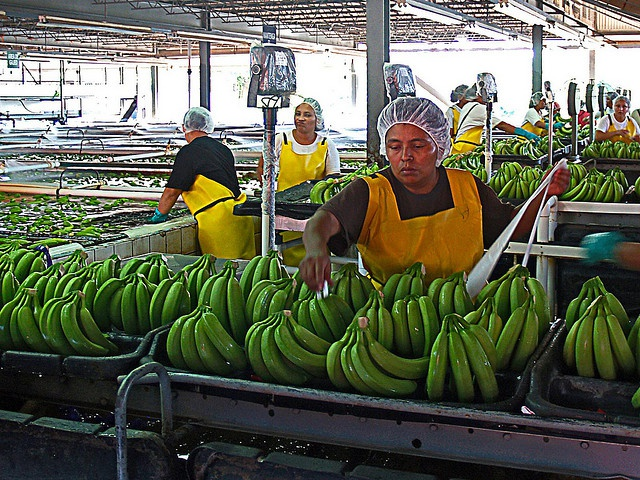Describe the objects in this image and their specific colors. I can see banana in black, darkgreen, and white tones, people in black, brown, maroon, and olive tones, people in black, olive, and gold tones, banana in black, darkgreen, and green tones, and banana in black, darkgreen, and green tones in this image. 